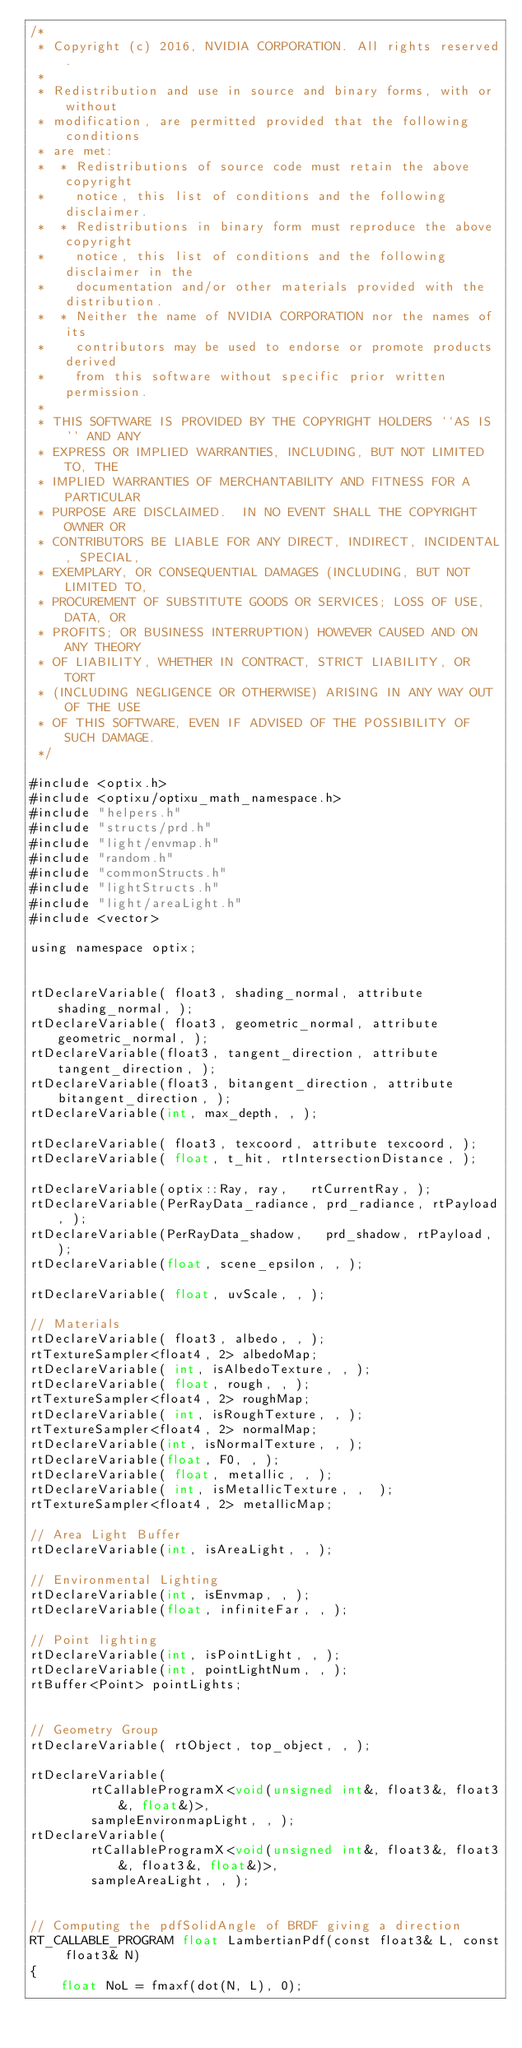<code> <loc_0><loc_0><loc_500><loc_500><_Cuda_>/* 
 * Copyright (c) 2016, NVIDIA CORPORATION. All rights reserved.
 *
 * Redistribution and use in source and binary forms, with or without
 * modification, are permitted provided that the following conditions
 * are met:
 *  * Redistributions of source code must retain the above copyright
 *    notice, this list of conditions and the following disclaimer.
 *  * Redistributions in binary form must reproduce the above copyright
 *    notice, this list of conditions and the following disclaimer in the
 *    documentation and/or other materials provided with the distribution.
 *  * Neither the name of NVIDIA CORPORATION nor the names of its
 *    contributors may be used to endorse or promote products derived
 *    from this software without specific prior written permission.
 *
 * THIS SOFTWARE IS PROVIDED BY THE COPYRIGHT HOLDERS ``AS IS'' AND ANY
 * EXPRESS OR IMPLIED WARRANTIES, INCLUDING, BUT NOT LIMITED TO, THE
 * IMPLIED WARRANTIES OF MERCHANTABILITY AND FITNESS FOR A PARTICULAR
 * PURPOSE ARE DISCLAIMED.  IN NO EVENT SHALL THE COPYRIGHT OWNER OR
 * CONTRIBUTORS BE LIABLE FOR ANY DIRECT, INDIRECT, INCIDENTAL, SPECIAL,
 * EXEMPLARY, OR CONSEQUENTIAL DAMAGES (INCLUDING, BUT NOT LIMITED TO,
 * PROCUREMENT OF SUBSTITUTE GOODS OR SERVICES; LOSS OF USE, DATA, OR
 * PROFITS; OR BUSINESS INTERRUPTION) HOWEVER CAUSED AND ON ANY THEORY
 * OF LIABILITY, WHETHER IN CONTRACT, STRICT LIABILITY, OR TORT
 * (INCLUDING NEGLIGENCE OR OTHERWISE) ARISING IN ANY WAY OUT OF THE USE
 * OF THIS SOFTWARE, EVEN IF ADVISED OF THE POSSIBILITY OF SUCH DAMAGE.
 */

#include <optix.h>
#include <optixu/optixu_math_namespace.h>
#include "helpers.h"
#include "structs/prd.h"
#include "light/envmap.h"
#include "random.h"
#include "commonStructs.h"
#include "lightStructs.h"
#include "light/areaLight.h"
#include <vector>

using namespace optix;


rtDeclareVariable( float3, shading_normal, attribute shading_normal, ); 
rtDeclareVariable( float3, geometric_normal, attribute geometric_normal, );
rtDeclareVariable(float3, tangent_direction, attribute tangent_direction, );
rtDeclareVariable(float3, bitangent_direction, attribute bitangent_direction, );
rtDeclareVariable(int, max_depth, , );

rtDeclareVariable( float3, texcoord, attribute texcoord, );
rtDeclareVariable( float, t_hit, rtIntersectionDistance, );

rtDeclareVariable(optix::Ray, ray,   rtCurrentRay, );
rtDeclareVariable(PerRayData_radiance, prd_radiance, rtPayload, );
rtDeclareVariable(PerRayData_shadow,   prd_shadow, rtPayload, );
rtDeclareVariable(float, scene_epsilon, , );

rtDeclareVariable( float, uvScale, , ); 

// Materials
rtDeclareVariable( float3, albedo, , );
rtTextureSampler<float4, 2> albedoMap;
rtDeclareVariable( int, isAlbedoTexture, , );
rtDeclareVariable( float, rough, , );
rtTextureSampler<float4, 2> roughMap;
rtDeclareVariable( int, isRoughTexture, , );
rtTextureSampler<float4, 2> normalMap;
rtDeclareVariable(int, isNormalTexture, , );
rtDeclareVariable(float, F0, , );
rtDeclareVariable( float, metallic, , );
rtDeclareVariable( int, isMetallicTexture, ,  );
rtTextureSampler<float4, 2> metallicMap;

// Area Light Buffer
rtDeclareVariable(int, isAreaLight, , );

// Environmental Lighting 
rtDeclareVariable(int, isEnvmap, , );
rtDeclareVariable(float, infiniteFar, , );

// Point lighting 
rtDeclareVariable(int, isPointLight, , );
rtDeclareVariable(int, pointLightNum, , );
rtBuffer<Point> pointLights;


// Geometry Group
rtDeclareVariable( rtObject, top_object, , );

rtDeclareVariable(
        rtCallableProgramX<void(unsigned int&, float3&, float3&, float&)>, 
        sampleEnvironmapLight, , );
rtDeclareVariable(
        rtCallableProgramX<void(unsigned int&, float3&, float3&, float3&, float&)>, 
        sampleAreaLight, , );


// Computing the pdfSolidAngle of BRDF giving a direction 
RT_CALLABLE_PROGRAM float LambertianPdf(const float3& L, const float3& N)
{
    float NoL = fmaxf(dot(N, L), 0);</code> 